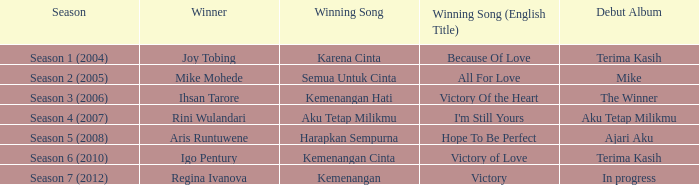Which winning song had a debut album in progress? Kemenangan. 